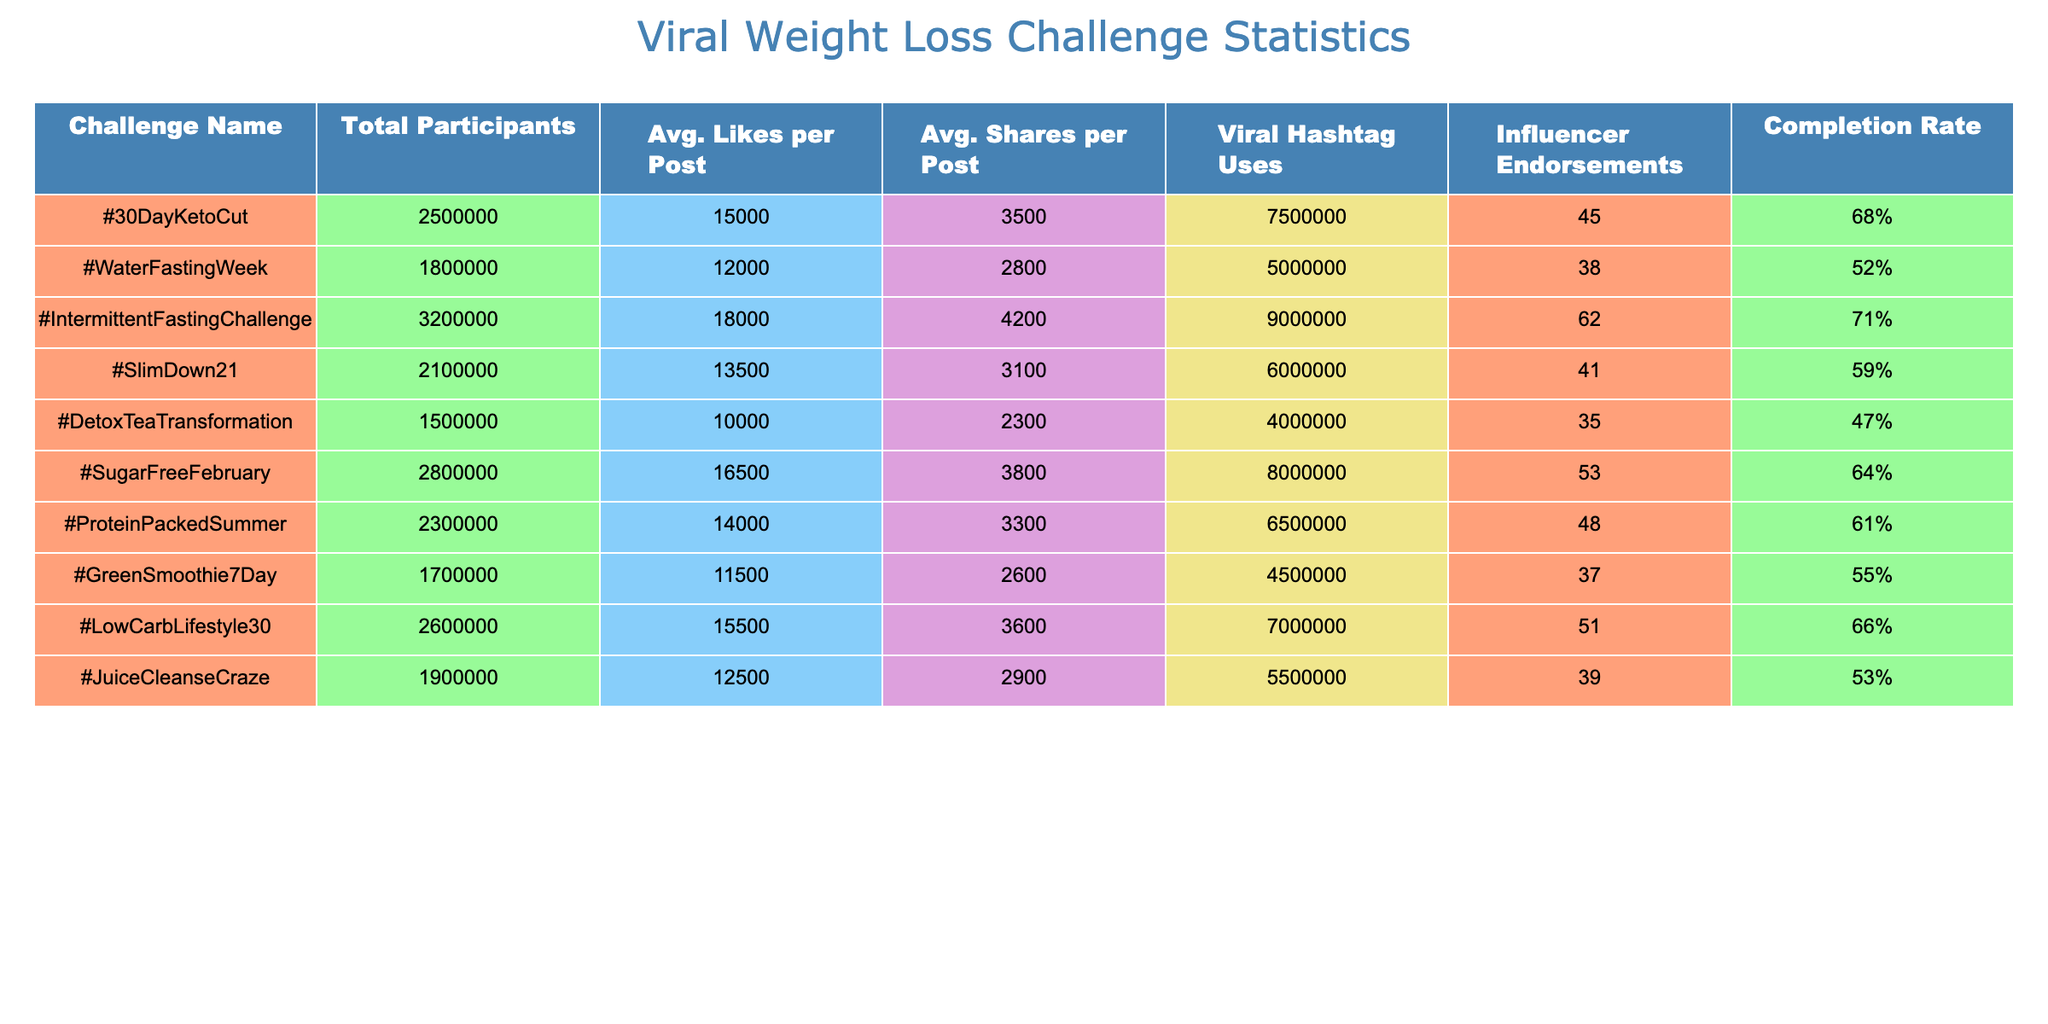What's the completion rate for the #30DayKetoCut challenge? The table shows that the completion rate for the #30DayKetoCut challenge is 68%, directly referenced from the "Completion Rate" column next to the challenge name.
Answer: 68% How many total participants took part in the #IntermittentFastingChallenge? The "Total Participants" column indicates that the #IntermittentFastingChallenge had 3,200,000 participants.
Answer: 3,200,000 Which challenge had the highest average likes per post? By comparing values in the "Avg. Likes per Post" column, the #IntermittentFastingChallenge has the highest average likes with 18,000.
Answer: #IntermittentFastingChallenge What is the average completion rate of all the challenges listed? To find the average completion rate, sum the percentages: 68 + 52 + 71 + 59 + 47 + 64 + 61 + 55 + 66 + 53 =  626%. Divide this by the number of challenges: 626 / 10 = 62.6%.
Answer: 62.6% How many challenges had more than 1.5 million participants? Counting the entries in the "Total Participants" column, the following challenges exceed 1.5 million: #30DayKetoCut, #WaterFastingWeek, #IntermittentFastingChallenge, #SlimDown21, #SugarFreeFebruary, #ProteinPackedSummer, #LowCarbLifestyle30, and #JuiceCleanseCraze. That's 8 challenges.
Answer: 8 Is there any challenge with over 60% completion rate that does not have an influencer endorsement? Reviewing the "Completion Rate" and "Influencer Endorsements" columns, the #DetoxTeaTransformation has a completion rate of 47% and no endorses. Therefore, it does not meet the criteria; all challenges with over 60% completion have endorsements.
Answer: No Which challenge has the highest number of influencer endorsements? The "Influencer Endorsements" column shows that the #IntermittentFastingChallenge has the highest endorsements at 62.
Answer: #IntermittentFastingChallenge What is the difference in average likes between the #30DayKetoCut and #DetoxTeaTransformation challenges? The average likes per post for #30DayKetoCut is 15,000 and #DetoxTeaTransformation is 10,000. The difference is 15,000 - 10,000 = 5,000.
Answer: 5,000 Which challenge has the lowest average shares per post? By analyzing the "Avg. Shares per Post" column, the #DetoxTeaTransformation has the lowest average shares at 2,300.
Answer: #DetoxTeaTransformation What is the total number of viral hashtag uses across all challenges? To find the total, sum all values in the "Viral Hashtag Uses" column: 7,500,000 + 5,000,000 + 9,000,000 + 6,000,000 + 4,000,000 + 8,000,000 + 6,500,000 + 4,500,000 + 7,000,000 + 5,500,000 = 57,000,000.
Answer: 57,000,000 Are there more challenges with a completion rate above 60% than those below? Comparing the completion rates, challenges above 60% are: #30DayKetoCut, #IntermittentFastingChallenge, #SugarFreeFebruary, #LowCarbLifestyle30, and #ProteinPackedSummer, giving 5 challenges. Those below are: #WaterFastingWeek, #SlimDown21, #DetoxTeaTransformation, and #JuiceCleanseCraze, totaling 4 challenges.
Answer: Yes 